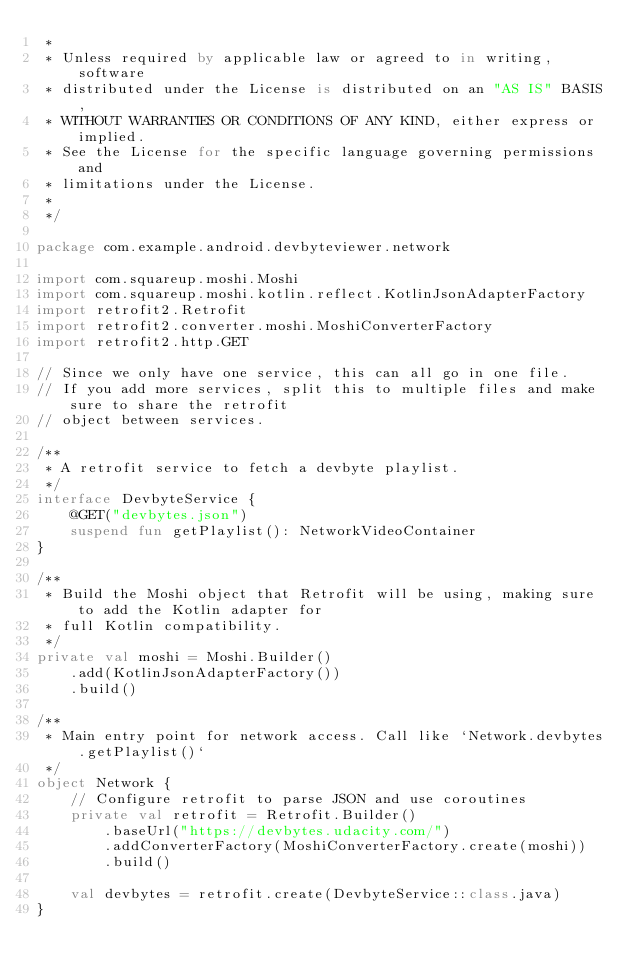<code> <loc_0><loc_0><loc_500><loc_500><_Kotlin_> *
 * Unless required by applicable law or agreed to in writing, software
 * distributed under the License is distributed on an "AS IS" BASIS,
 * WITHOUT WARRANTIES OR CONDITIONS OF ANY KIND, either express or implied.
 * See the License for the specific language governing permissions and
 * limitations under the License.
 *
 */

package com.example.android.devbyteviewer.network

import com.squareup.moshi.Moshi
import com.squareup.moshi.kotlin.reflect.KotlinJsonAdapterFactory
import retrofit2.Retrofit
import retrofit2.converter.moshi.MoshiConverterFactory
import retrofit2.http.GET

// Since we only have one service, this can all go in one file.
// If you add more services, split this to multiple files and make sure to share the retrofit
// object between services.

/**
 * A retrofit service to fetch a devbyte playlist.
 */
interface DevbyteService {
    @GET("devbytes.json")
    suspend fun getPlaylist(): NetworkVideoContainer
}

/**
 * Build the Moshi object that Retrofit will be using, making sure to add the Kotlin adapter for
 * full Kotlin compatibility.
 */
private val moshi = Moshi.Builder()
    .add(KotlinJsonAdapterFactory())
    .build()

/**
 * Main entry point for network access. Call like `Network.devbytes.getPlaylist()`
 */
object Network {
    // Configure retrofit to parse JSON and use coroutines
    private val retrofit = Retrofit.Builder()
        .baseUrl("https://devbytes.udacity.com/")
        .addConverterFactory(MoshiConverterFactory.create(moshi))
        .build()

    val devbytes = retrofit.create(DevbyteService::class.java)
}
</code> 